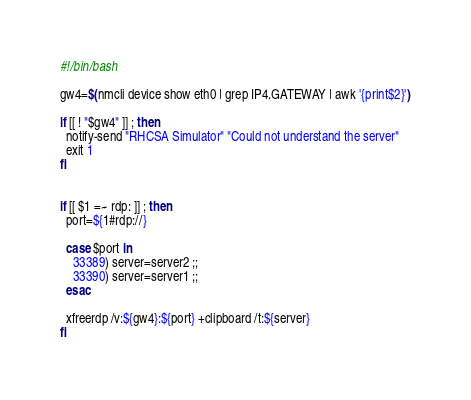<code> <loc_0><loc_0><loc_500><loc_500><_Bash_>#!/bin/bash

gw4=$(nmcli device show eth0 | grep IP4.GATEWAY | awk '{print$2}')

if [[ ! "$gw4" ]] ; then
  notify-send "RHCSA Simulator" "Could not understand the server"
  exit 1
fi


if [[ $1 =~ rdp: ]] ; then
  port=${1#rdp://}

  case $port in
    33389) server=server2 ;;
    33390) server=server1 ;;
  esac

  xfreerdp /v:${gw4}:${port} +clipboard /t:${server}
fi</code> 